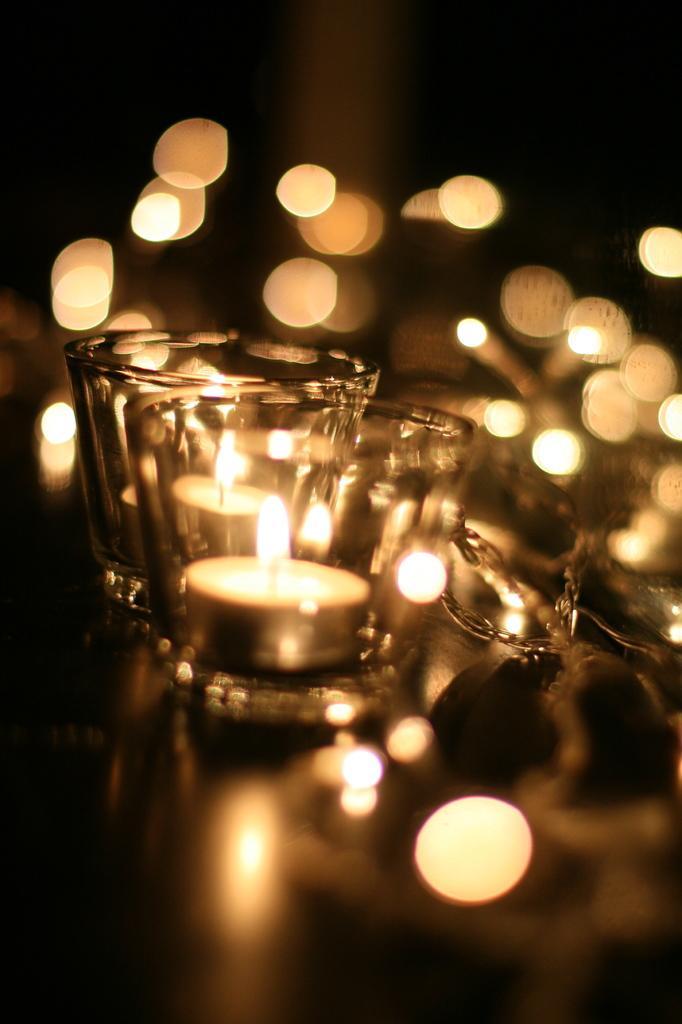Please provide a concise description of this image. In this picture, there are two glasses. In each glass, there is a candle with fire. 